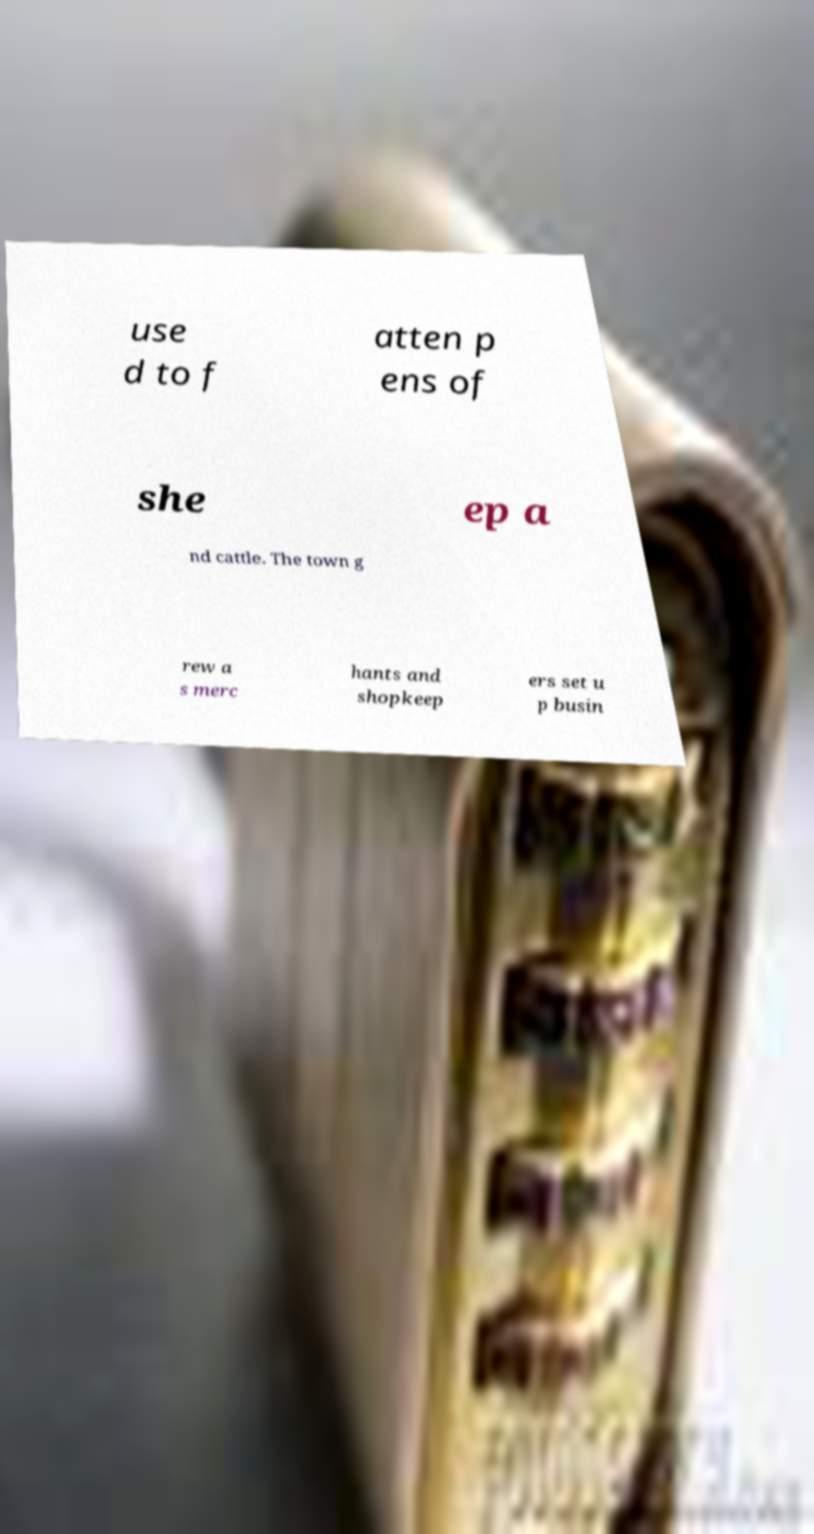Could you assist in decoding the text presented in this image and type it out clearly? use d to f atten p ens of she ep a nd cattle. The town g rew a s merc hants and shopkeep ers set u p busin 